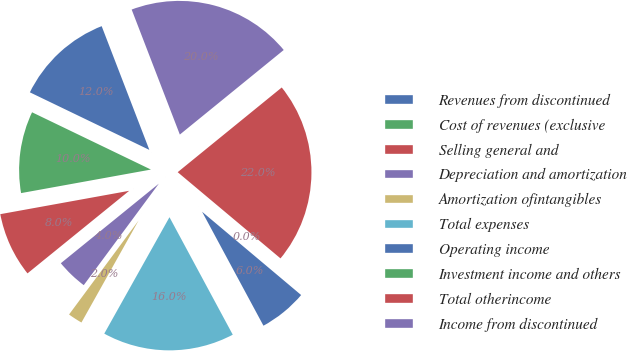<chart> <loc_0><loc_0><loc_500><loc_500><pie_chart><fcel>Revenues from discontinued<fcel>Cost of revenues (exclusive<fcel>Selling general and<fcel>Depreciation and amortization<fcel>Amortization ofintangibles<fcel>Total expenses<fcel>Operating income<fcel>Investment income and others<fcel>Total otherincome<fcel>Income from discontinued<nl><fcel>12.0%<fcel>10.0%<fcel>8.0%<fcel>4.01%<fcel>2.01%<fcel>15.99%<fcel>6.01%<fcel>0.02%<fcel>21.98%<fcel>19.98%<nl></chart> 